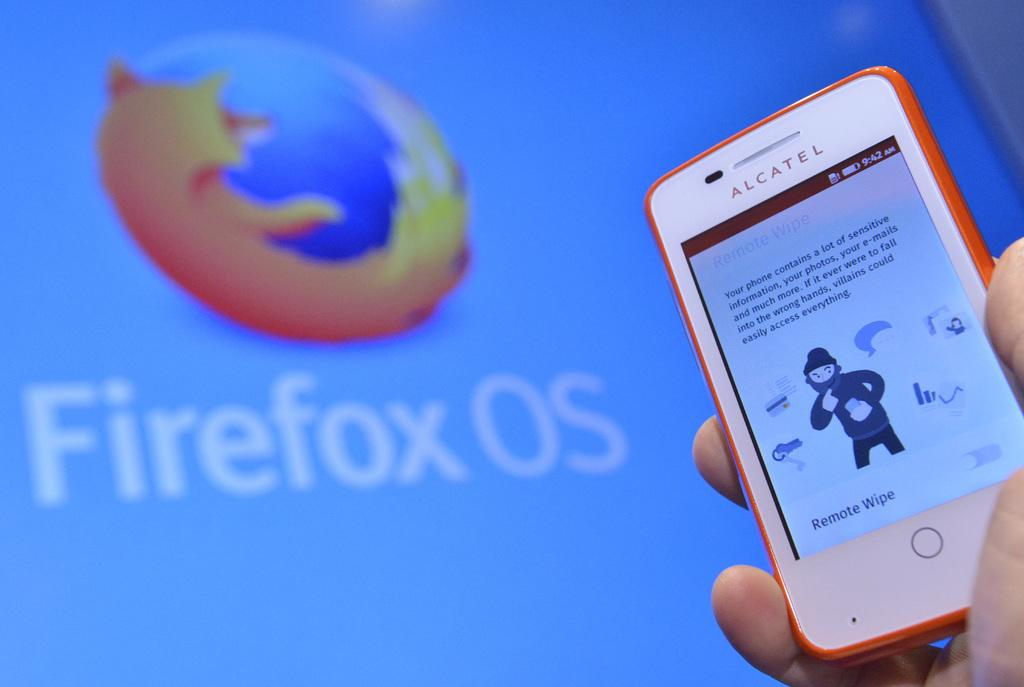<image>
Give a short and clear explanation of the subsequent image. A hand is holding a small Alcatel cellphone in front of a large screen displaying Firefox OS. 